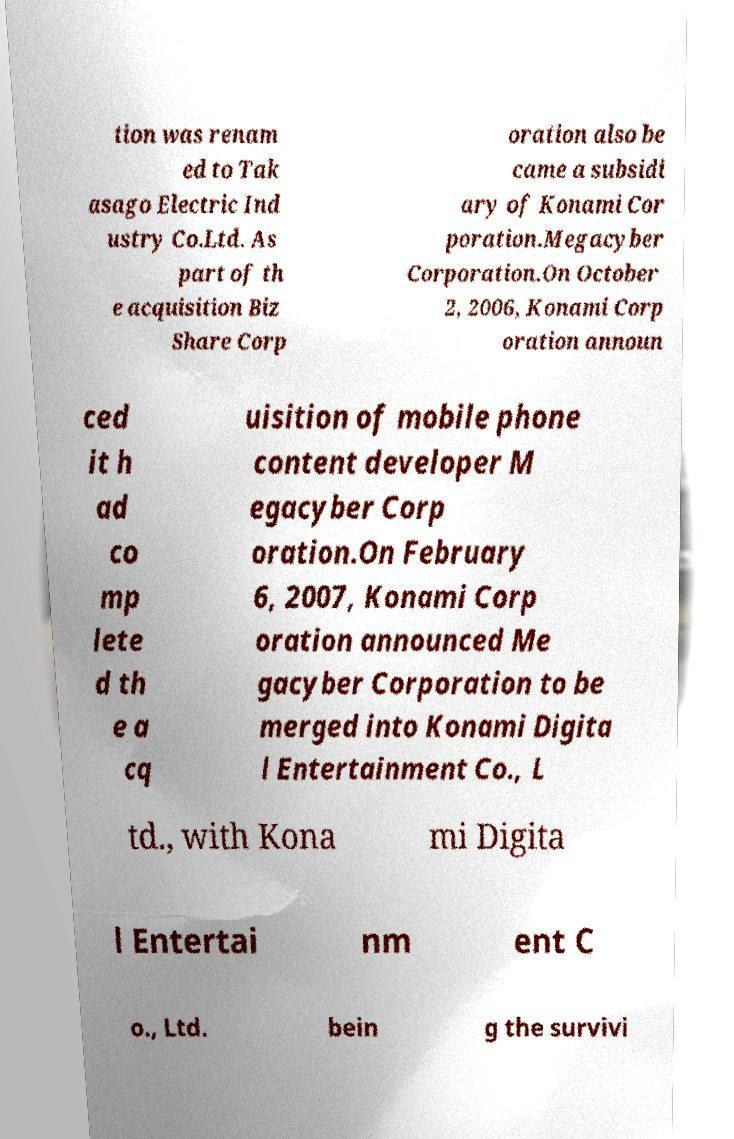Please read and relay the text visible in this image. What does it say? tion was renam ed to Tak asago Electric Ind ustry Co.Ltd. As part of th e acquisition Biz Share Corp oration also be came a subsidi ary of Konami Cor poration.Megacyber Corporation.On October 2, 2006, Konami Corp oration announ ced it h ad co mp lete d th e a cq uisition of mobile phone content developer M egacyber Corp oration.On February 6, 2007, Konami Corp oration announced Me gacyber Corporation to be merged into Konami Digita l Entertainment Co., L td., with Kona mi Digita l Entertai nm ent C o., Ltd. bein g the survivi 